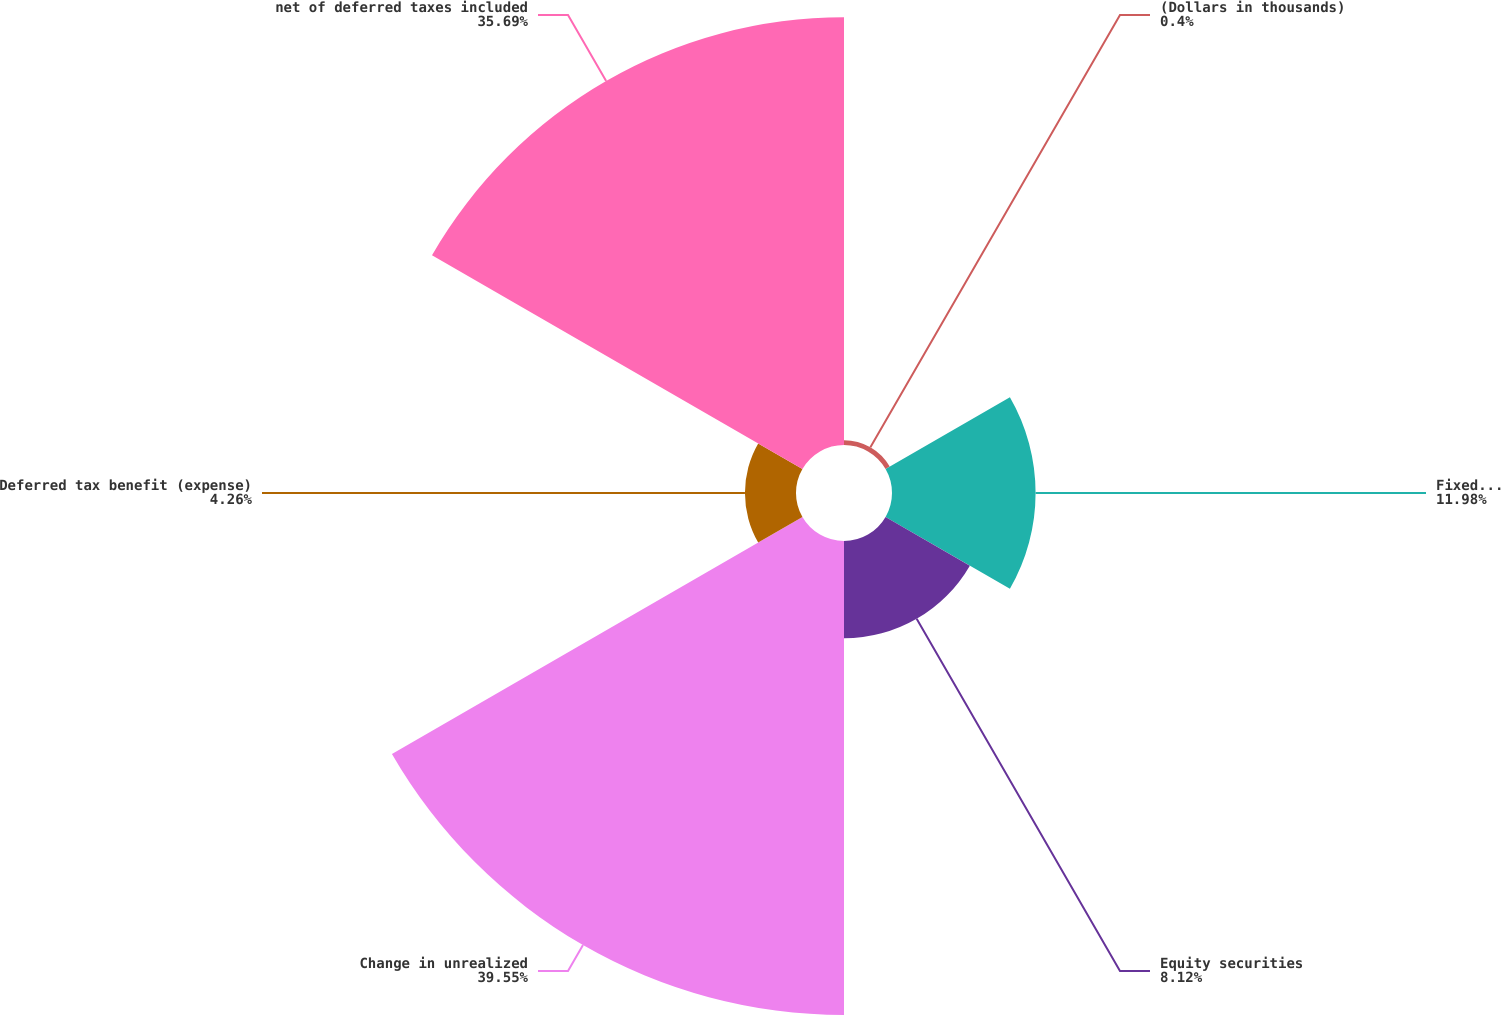Convert chart. <chart><loc_0><loc_0><loc_500><loc_500><pie_chart><fcel>(Dollars in thousands)<fcel>Fixed maturity securities<fcel>Equity securities<fcel>Change in unrealized<fcel>Deferred tax benefit (expense)<fcel>net of deferred taxes included<nl><fcel>0.4%<fcel>11.98%<fcel>8.12%<fcel>39.55%<fcel>4.26%<fcel>35.69%<nl></chart> 